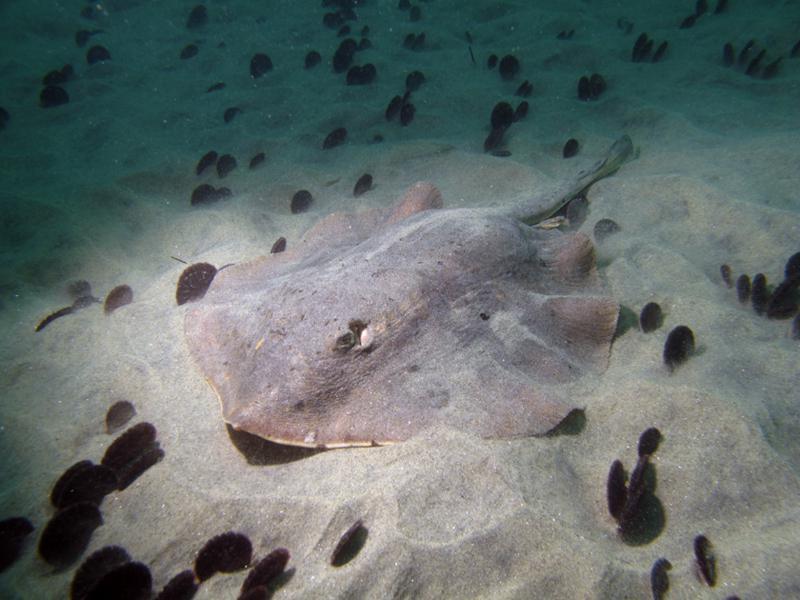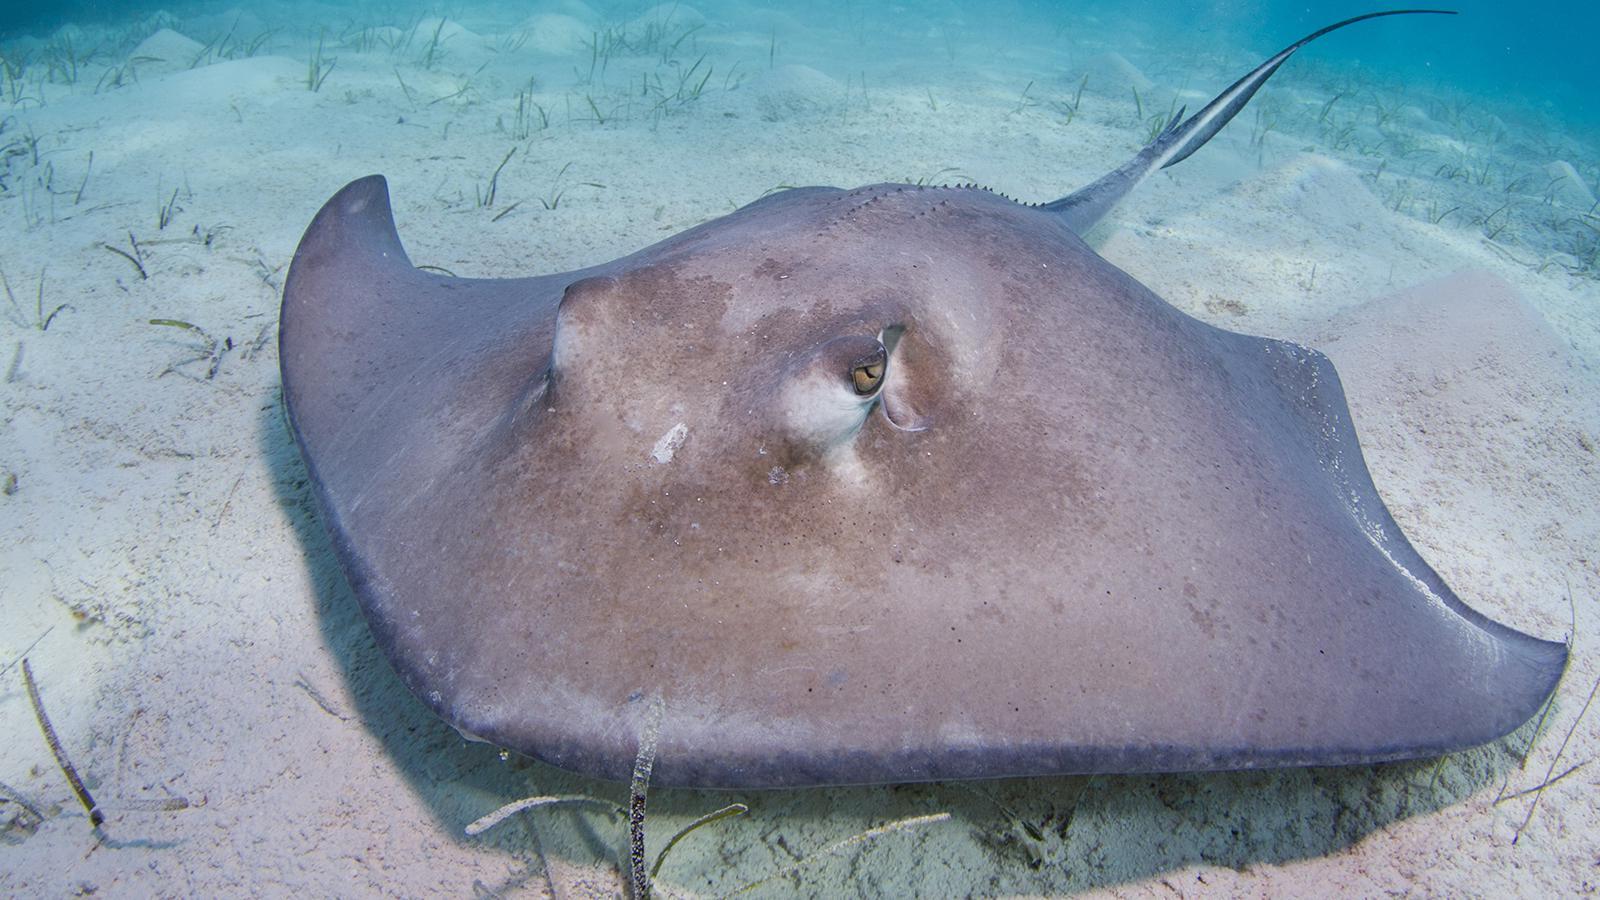The first image is the image on the left, the second image is the image on the right. Evaluate the accuracy of this statement regarding the images: "At least one stingray's underside is visible.". Is it true? Answer yes or no. No. 